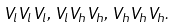<formula> <loc_0><loc_0><loc_500><loc_500>V _ { l } V _ { l } V _ { l } , \, V _ { l } V _ { h } V _ { h } , \, V _ { h } V _ { h } V _ { h } .</formula> 